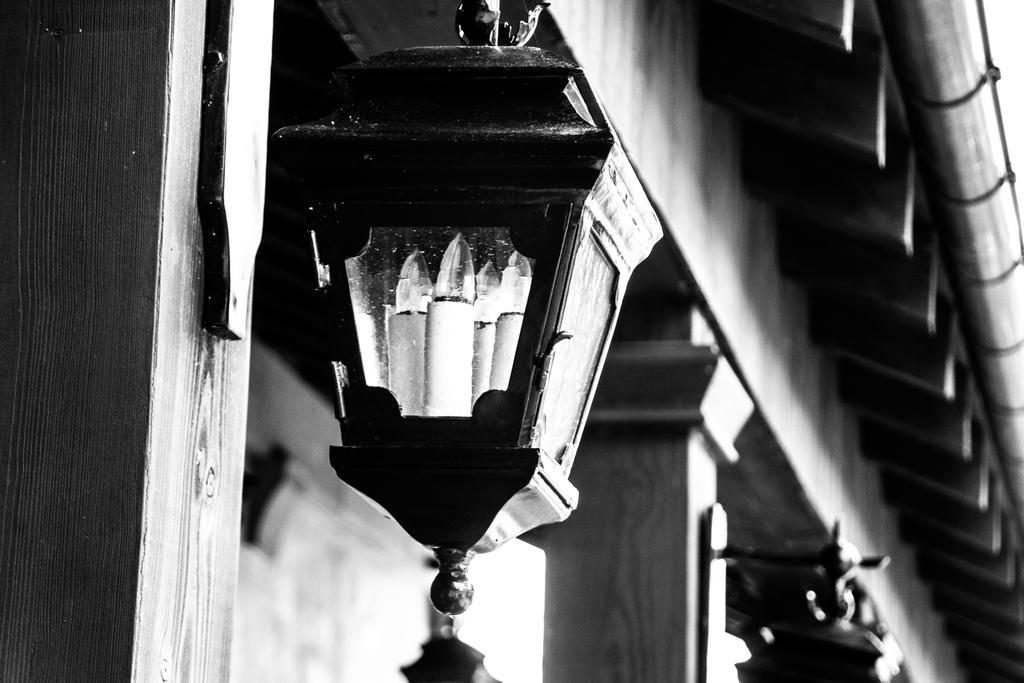Please provide a concise description of this image. It is a black and white image. In this image in front there is a light. There are pillars. On top of the image there is a ceiling. In the background of the image there is a wall. 